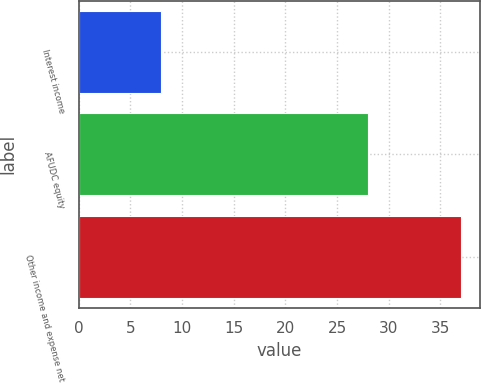<chart> <loc_0><loc_0><loc_500><loc_500><bar_chart><fcel>Interest income<fcel>AFUDC equity<fcel>Other income and expense net<nl><fcel>8<fcel>28<fcel>37<nl></chart> 